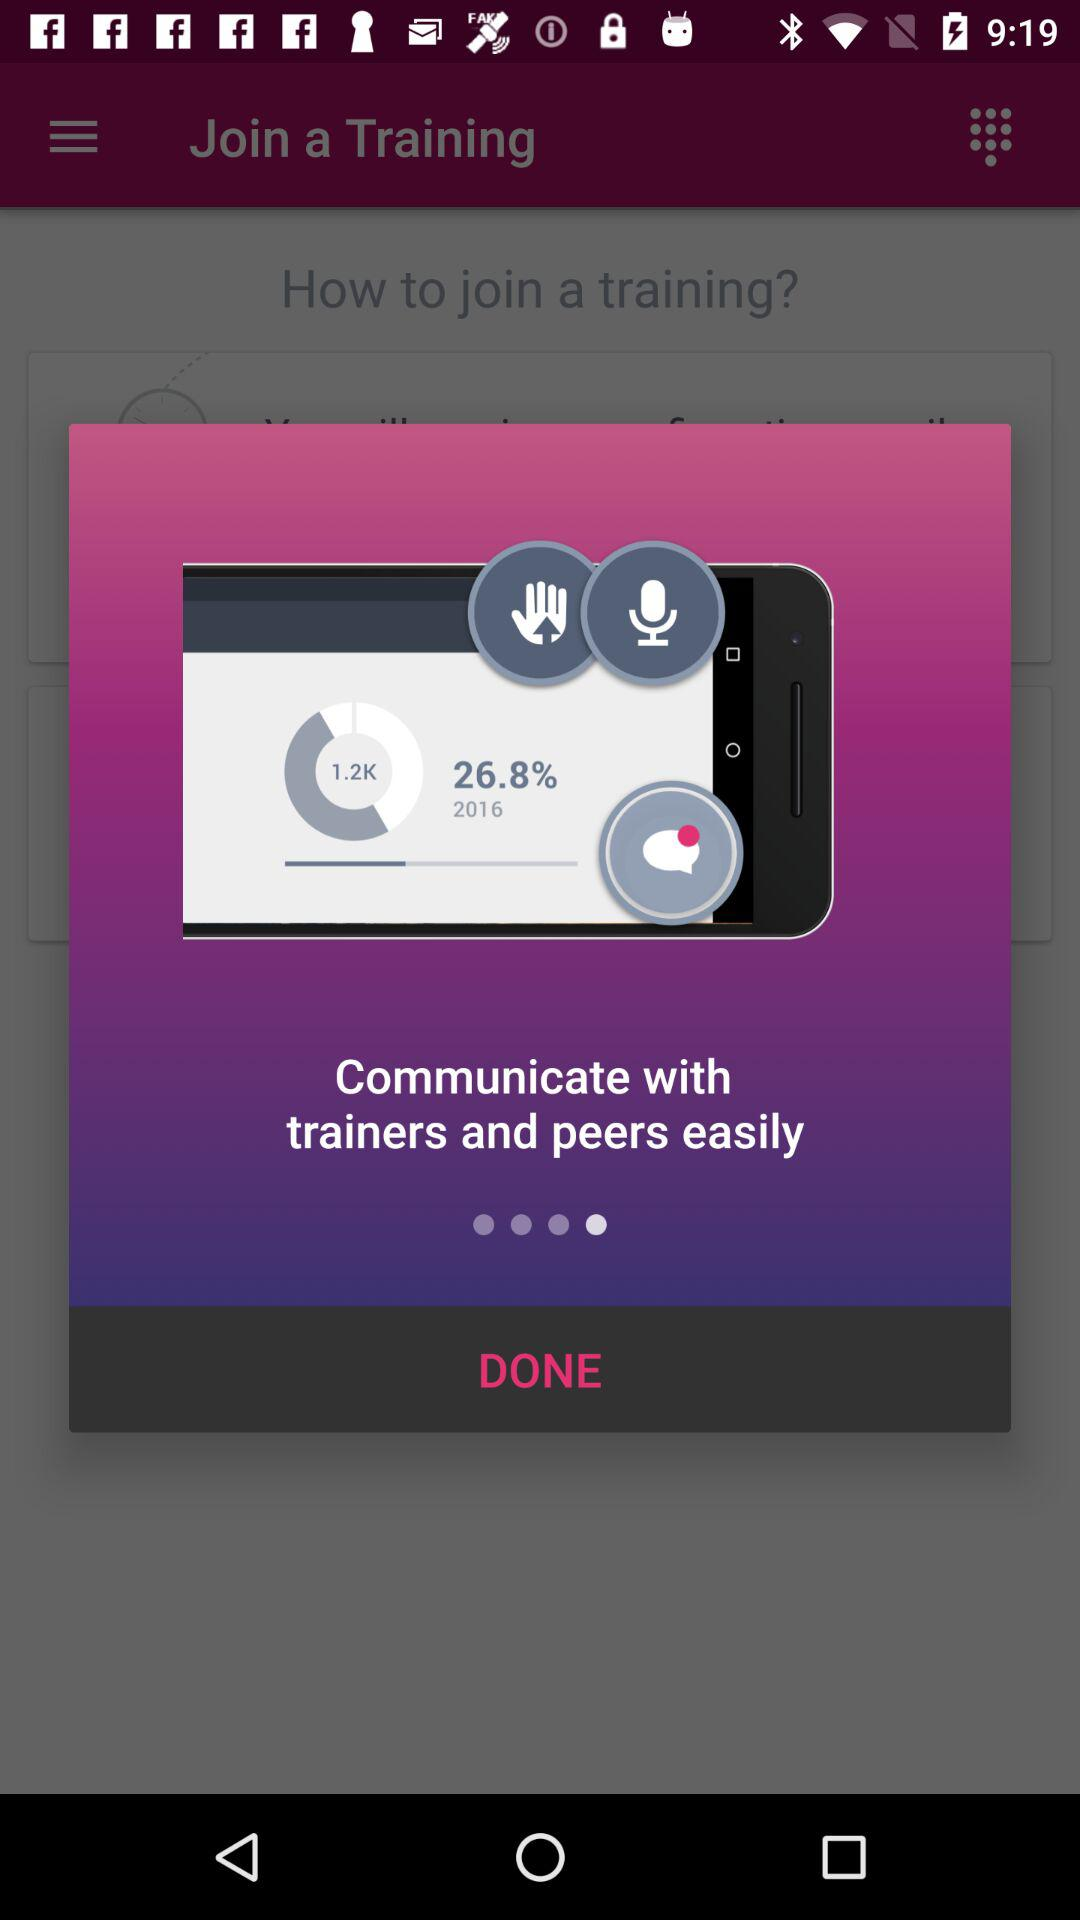What is the uploaded percentage? The uploaded percentage is 26.8. 